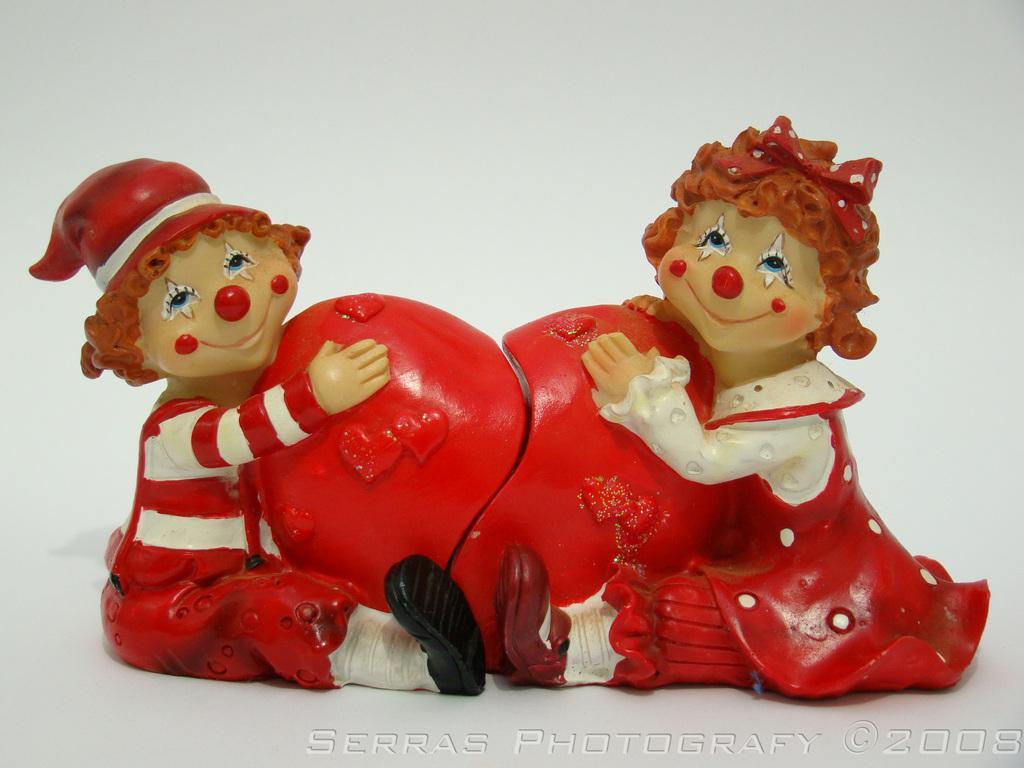Can you describe this image briefly? In the image we can see two toys, white, red and cream in colors. The surface and the background is white and on the bottom right we can see the watermark. 